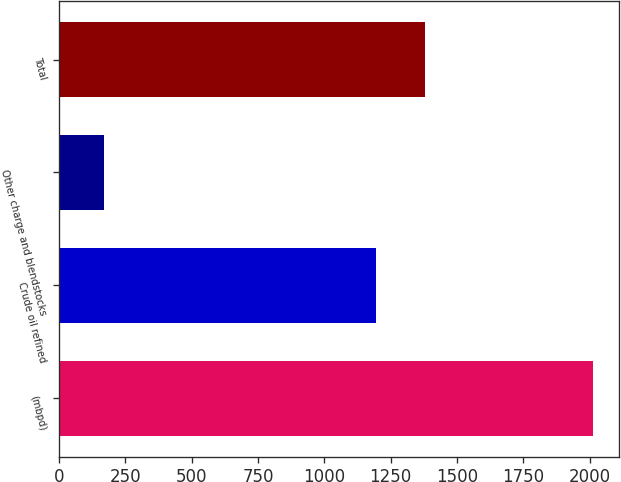<chart> <loc_0><loc_0><loc_500><loc_500><bar_chart><fcel>(mbpd)<fcel>Crude oil refined<fcel>Other charge and blendstocks<fcel>Total<nl><fcel>2012<fcel>1195<fcel>168<fcel>1379.4<nl></chart> 